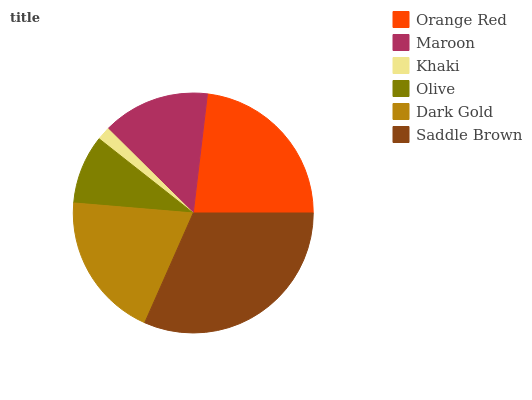Is Khaki the minimum?
Answer yes or no. Yes. Is Saddle Brown the maximum?
Answer yes or no. Yes. Is Maroon the minimum?
Answer yes or no. No. Is Maroon the maximum?
Answer yes or no. No. Is Orange Red greater than Maroon?
Answer yes or no. Yes. Is Maroon less than Orange Red?
Answer yes or no. Yes. Is Maroon greater than Orange Red?
Answer yes or no. No. Is Orange Red less than Maroon?
Answer yes or no. No. Is Dark Gold the high median?
Answer yes or no. Yes. Is Maroon the low median?
Answer yes or no. Yes. Is Maroon the high median?
Answer yes or no. No. Is Khaki the low median?
Answer yes or no. No. 